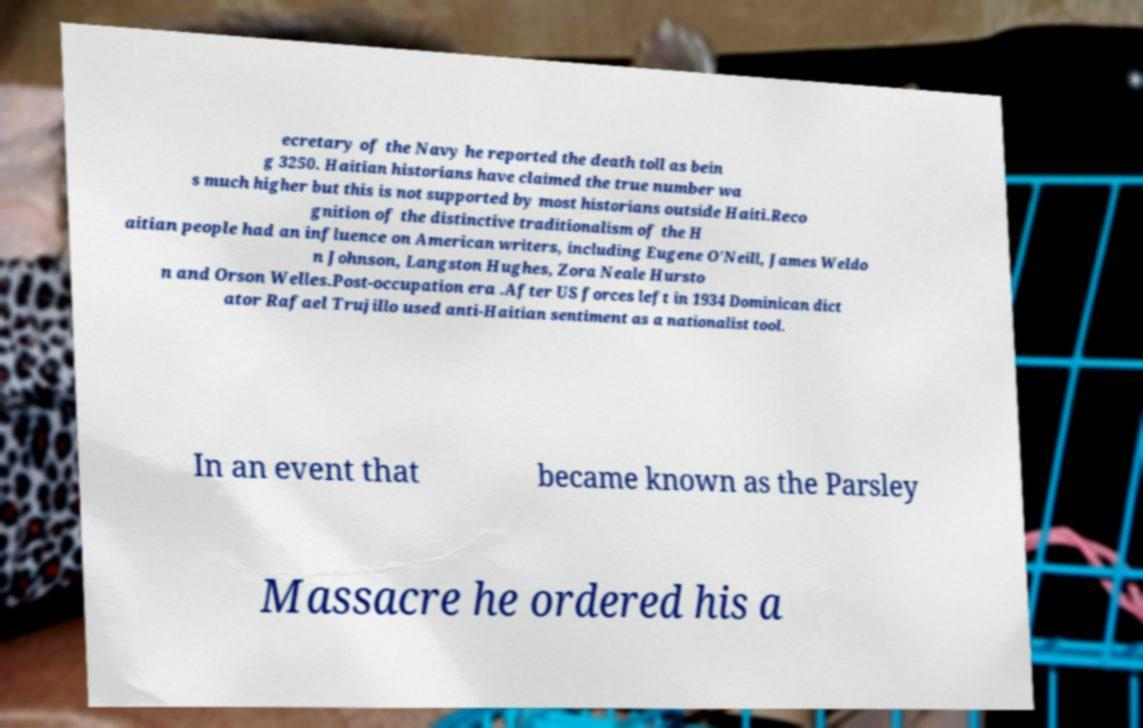I need the written content from this picture converted into text. Can you do that? ecretary of the Navy he reported the death toll as bein g 3250. Haitian historians have claimed the true number wa s much higher but this is not supported by most historians outside Haiti.Reco gnition of the distinctive traditionalism of the H aitian people had an influence on American writers, including Eugene O'Neill, James Weldo n Johnson, Langston Hughes, Zora Neale Hursto n and Orson Welles.Post-occupation era .After US forces left in 1934 Dominican dict ator Rafael Trujillo used anti-Haitian sentiment as a nationalist tool. In an event that became known as the Parsley Massacre he ordered his a 